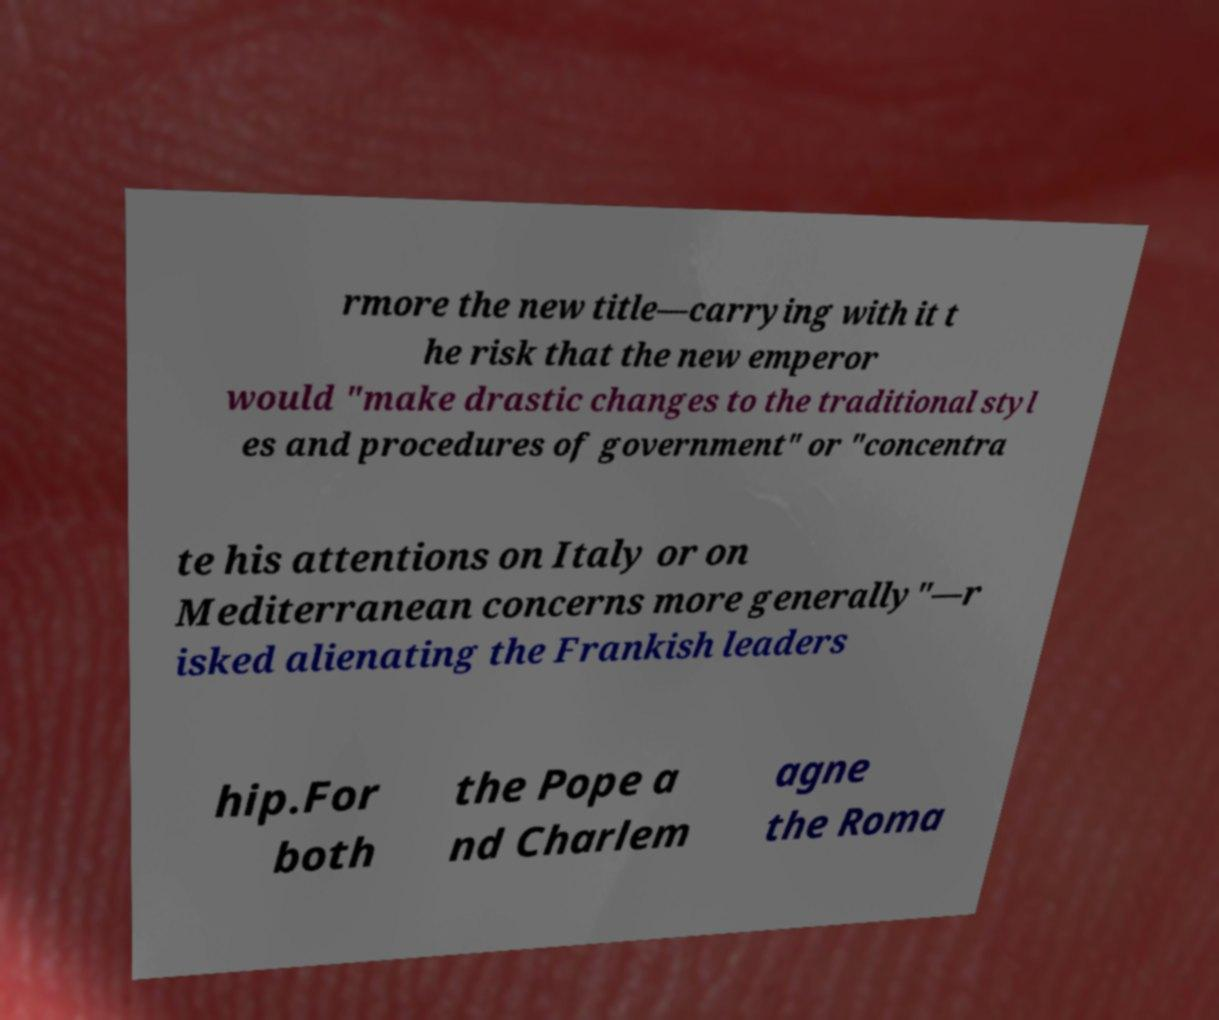Can you accurately transcribe the text from the provided image for me? rmore the new title—carrying with it t he risk that the new emperor would "make drastic changes to the traditional styl es and procedures of government" or "concentra te his attentions on Italy or on Mediterranean concerns more generally"—r isked alienating the Frankish leaders hip.For both the Pope a nd Charlem agne the Roma 